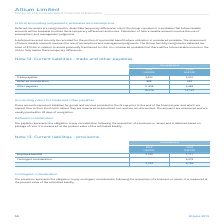From Altium Limited's financial document, What are the components of the liabilities? The document contains multiple relevant values: Trade payables, Deferred consideration, Other payables. From the document: "Trade payables 3,492 2,016 Other payables 11,898 9,488 Deferred consideration 888 643..." Also, What are the years included in the table? The document shows two values: 2019 and 2018. From the document: "30 June 2019 55 2018..." Also, How is the payable measured? It is measured at the present value of the estimated liability.. The document states: "passage of time. It is measured at the present value of the estimated liability...." Also, can you calculate: What is the percentage increase in the total trade and other payables from 2018 to 2019? To answer this question, I need to perform calculations using the financial data. The calculation is: (16,278-12,147)/12,147, which equals 34.01 (percentage). This is based on the information: "16,278 12,147 16,278 12,147..." The key data points involved are: 12,147, 16,278. Also, can you calculate: What is the percentage of trade payables as a ratio of current liabilities  in 2019? Based on the calculation: 3,492/16,278, the result is 21.45 (percentage). This is based on the information: "Trade payables 3,492 2,016 16,278 12,147..." The key data points involved are: 16,278, 3,492. Also, can you calculate: What is the percentage increase in other payables from 2018 to 2019? To answer this question, I need to perform calculations using the financial data. The calculation is: (11,898-9,488)/9,488, which equals 25.4 (percentage). This is based on the information: "Other payables 11,898 9,488 Other payables 11,898 9,488..." The key data points involved are: 11,898, 9,488. 